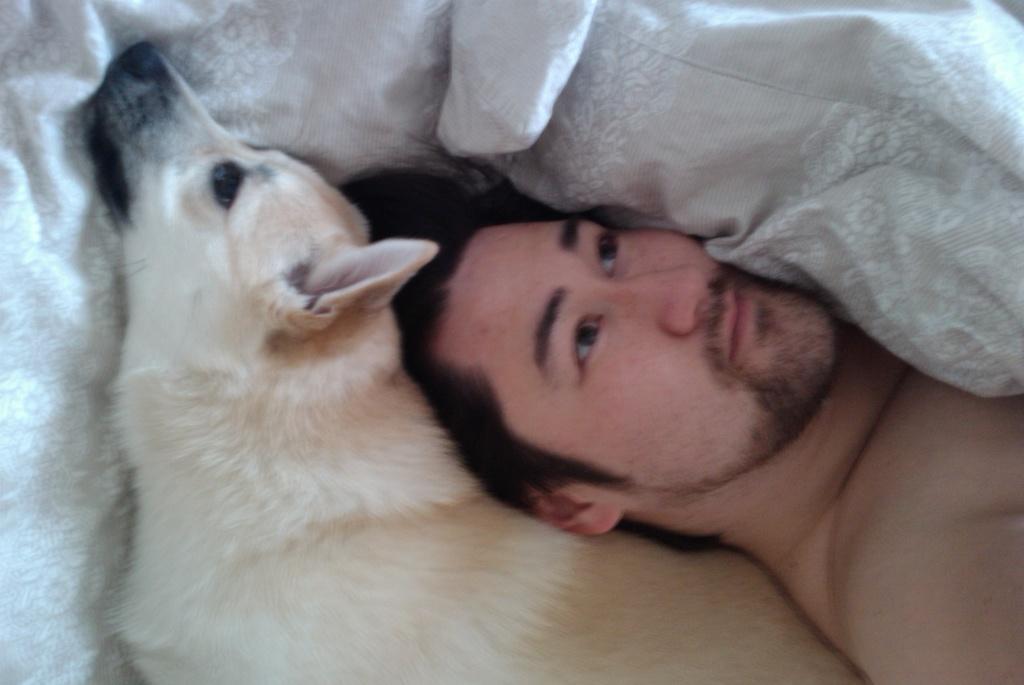In one or two sentences, can you explain what this image depicts? In this image I can see a person and white color dog sleeping on the bed. I can see a white color blanket. 